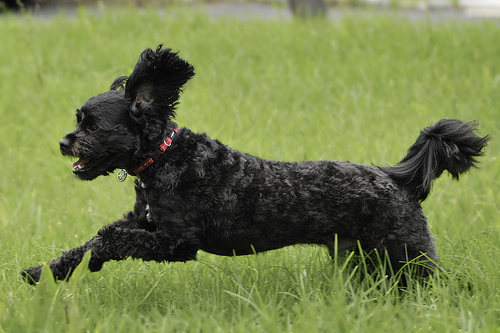<image>
Is the head on the collar? No. The head is not positioned on the collar. They may be near each other, but the head is not supported by or resting on top of the collar. 